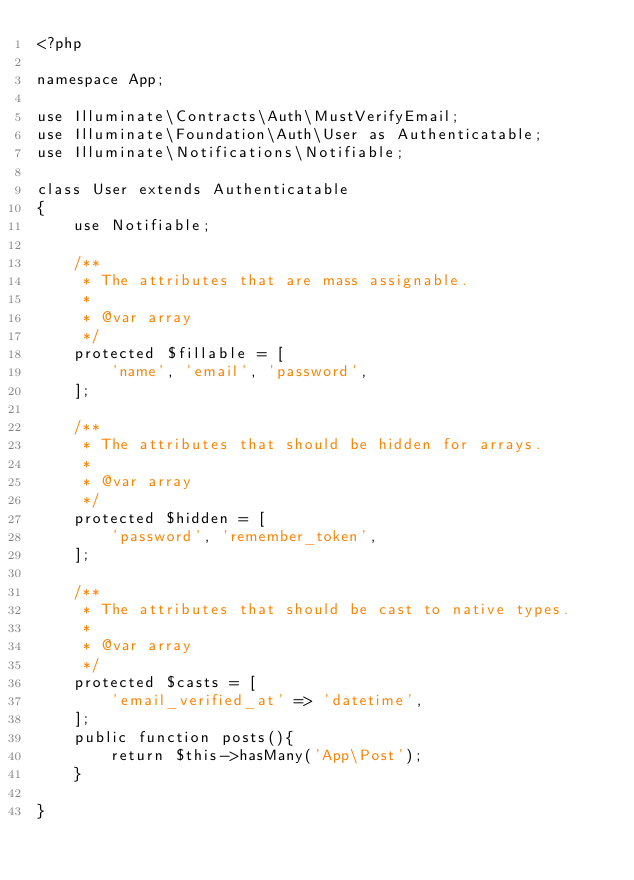Convert code to text. <code><loc_0><loc_0><loc_500><loc_500><_PHP_><?php

namespace App;

use Illuminate\Contracts\Auth\MustVerifyEmail;
use Illuminate\Foundation\Auth\User as Authenticatable;
use Illuminate\Notifications\Notifiable;

class User extends Authenticatable 
{
    use Notifiable;

    /**
     * The attributes that are mass assignable.
     *
     * @var array
     */
    protected $fillable = [
        'name', 'email', 'password',
    ];

    /**
     * The attributes that should be hidden for arrays.
     *
     * @var array
     */
    protected $hidden = [
        'password', 'remember_token',
    ];

    /**
     * The attributes that should be cast to native types.
     *
     * @var array
     */
    protected $casts = [
        'email_verified_at' => 'datetime',
    ];
    public function posts(){
        return $this->hasMany('App\Post');
    }
   
}
</code> 